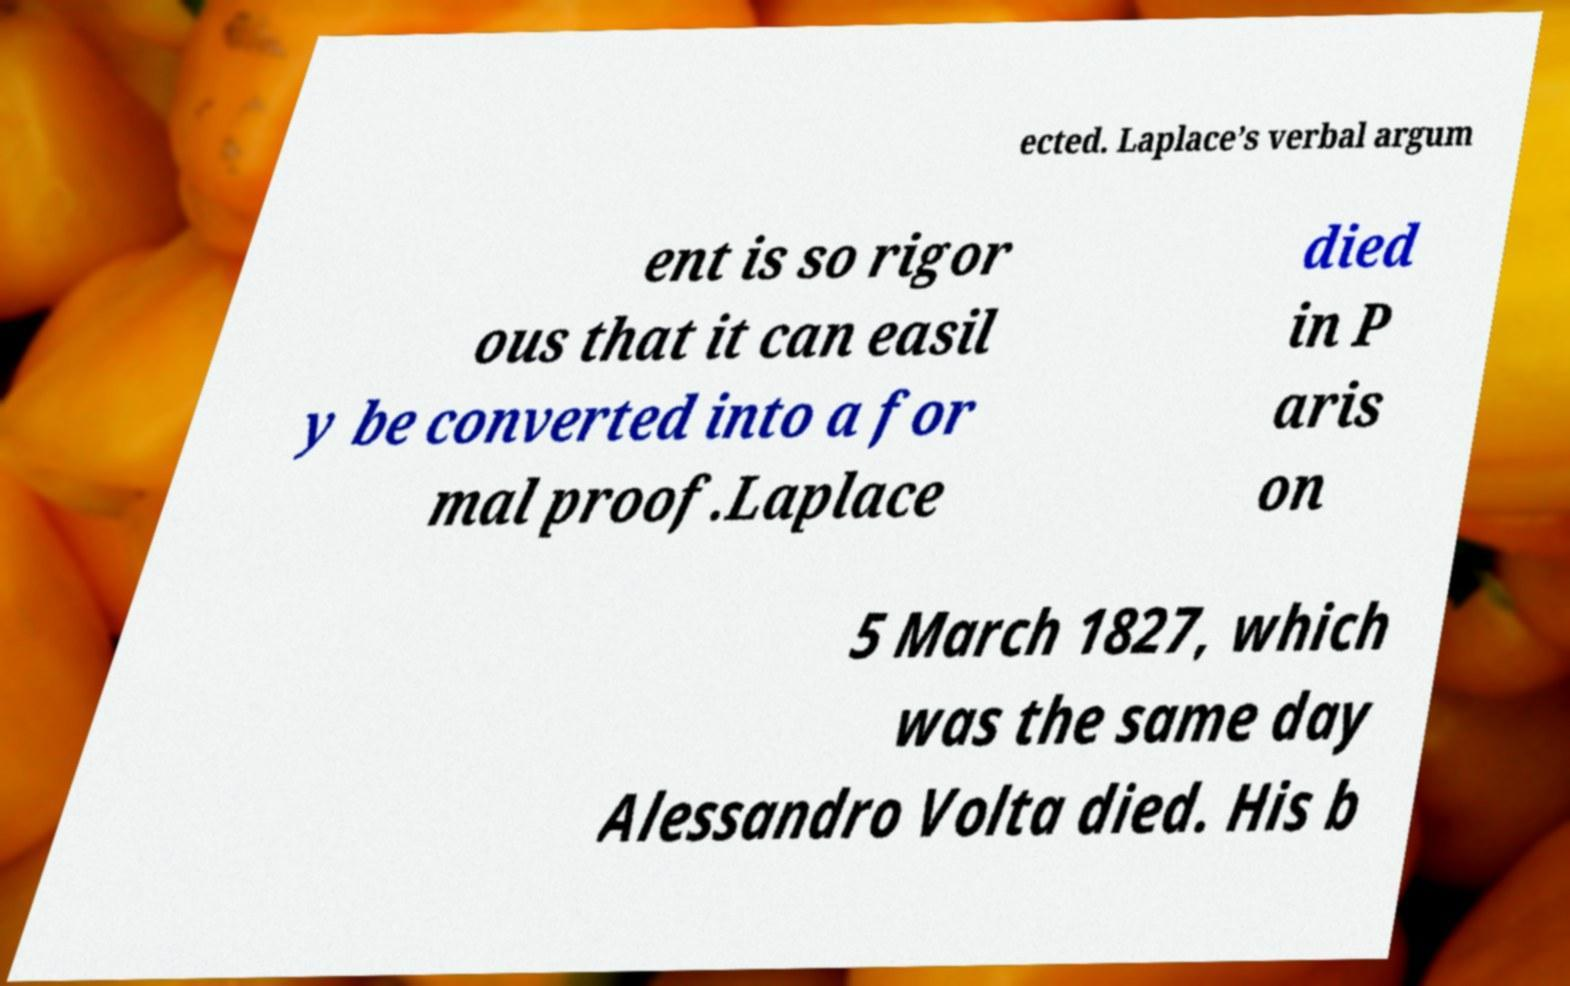Can you read and provide the text displayed in the image?This photo seems to have some interesting text. Can you extract and type it out for me? ected. Laplace’s verbal argum ent is so rigor ous that it can easil y be converted into a for mal proof.Laplace died in P aris on 5 March 1827, which was the same day Alessandro Volta died. His b 